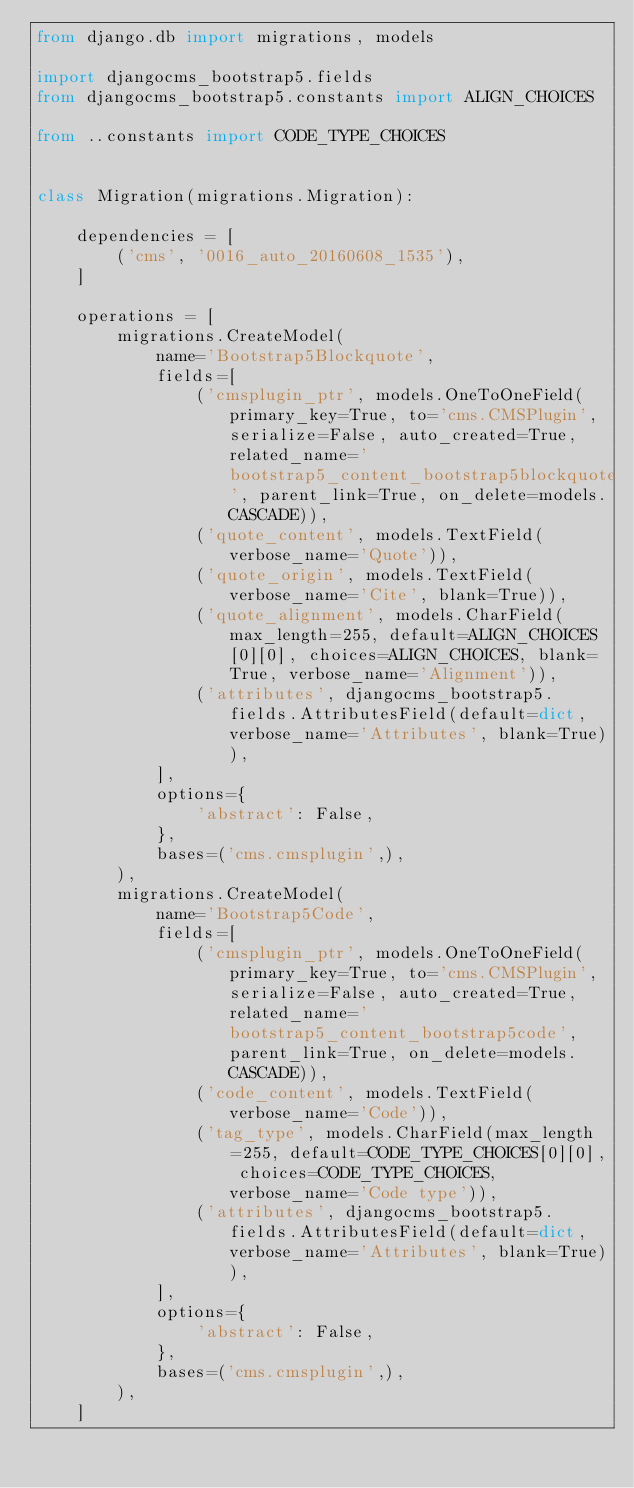<code> <loc_0><loc_0><loc_500><loc_500><_Python_>from django.db import migrations, models

import djangocms_bootstrap5.fields
from djangocms_bootstrap5.constants import ALIGN_CHOICES

from ..constants import CODE_TYPE_CHOICES


class Migration(migrations.Migration):

    dependencies = [
        ('cms', '0016_auto_20160608_1535'),
    ]

    operations = [
        migrations.CreateModel(
            name='Bootstrap5Blockquote',
            fields=[
                ('cmsplugin_ptr', models.OneToOneField(primary_key=True, to='cms.CMSPlugin', serialize=False, auto_created=True, related_name='bootstrap5_content_bootstrap5blockquote', parent_link=True, on_delete=models.CASCADE)),
                ('quote_content', models.TextField(verbose_name='Quote')),
                ('quote_origin', models.TextField(verbose_name='Cite', blank=True)),
                ('quote_alignment', models.CharField(max_length=255, default=ALIGN_CHOICES[0][0], choices=ALIGN_CHOICES, blank=True, verbose_name='Alignment')),
                ('attributes', djangocms_bootstrap5.fields.AttributesField(default=dict, verbose_name='Attributes', blank=True)),
            ],
            options={
                'abstract': False,
            },
            bases=('cms.cmsplugin',),
        ),
        migrations.CreateModel(
            name='Bootstrap5Code',
            fields=[
                ('cmsplugin_ptr', models.OneToOneField(primary_key=True, to='cms.CMSPlugin', serialize=False, auto_created=True, related_name='bootstrap5_content_bootstrap5code', parent_link=True, on_delete=models.CASCADE)),
                ('code_content', models.TextField(verbose_name='Code')),
                ('tag_type', models.CharField(max_length=255, default=CODE_TYPE_CHOICES[0][0], choices=CODE_TYPE_CHOICES, verbose_name='Code type')),
                ('attributes', djangocms_bootstrap5.fields.AttributesField(default=dict, verbose_name='Attributes', blank=True)),
            ],
            options={
                'abstract': False,
            },
            bases=('cms.cmsplugin',),
        ),
    ]
</code> 